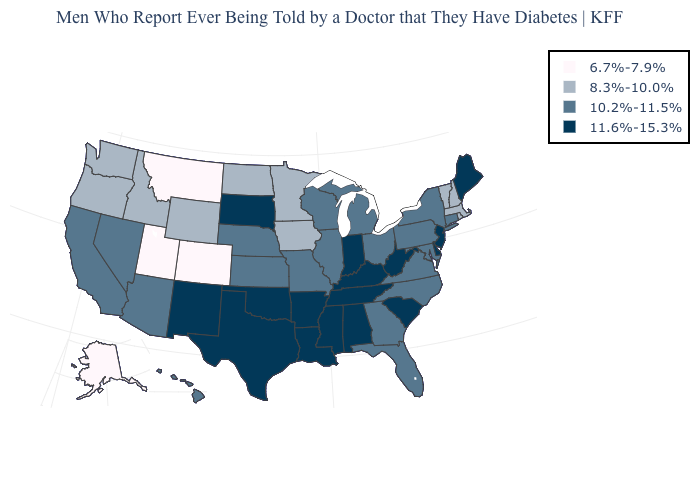What is the value of Connecticut?
Quick response, please. 10.2%-11.5%. Name the states that have a value in the range 6.7%-7.9%?
Write a very short answer. Alaska, Colorado, Montana, Utah. Name the states that have a value in the range 8.3%-10.0%?
Be succinct. Idaho, Iowa, Massachusetts, Minnesota, New Hampshire, North Dakota, Oregon, Rhode Island, Vermont, Washington, Wyoming. What is the lowest value in states that border Massachusetts?
Be succinct. 8.3%-10.0%. Which states have the lowest value in the Northeast?
Concise answer only. Massachusetts, New Hampshire, Rhode Island, Vermont. How many symbols are there in the legend?
Keep it brief. 4. What is the highest value in the Northeast ?
Keep it brief. 11.6%-15.3%. Name the states that have a value in the range 6.7%-7.9%?
Keep it brief. Alaska, Colorado, Montana, Utah. What is the value of Wyoming?
Short answer required. 8.3%-10.0%. What is the value of South Carolina?
Answer briefly. 11.6%-15.3%. Which states have the highest value in the USA?
Quick response, please. Alabama, Arkansas, Delaware, Indiana, Kentucky, Louisiana, Maine, Mississippi, New Jersey, New Mexico, Oklahoma, South Carolina, South Dakota, Tennessee, Texas, West Virginia. Does Washington have a lower value than Idaho?
Concise answer only. No. What is the value of West Virginia?
Short answer required. 11.6%-15.3%. Among the states that border Nebraska , does Kansas have the lowest value?
Short answer required. No. Does Wyoming have the lowest value in the USA?
Keep it brief. No. 